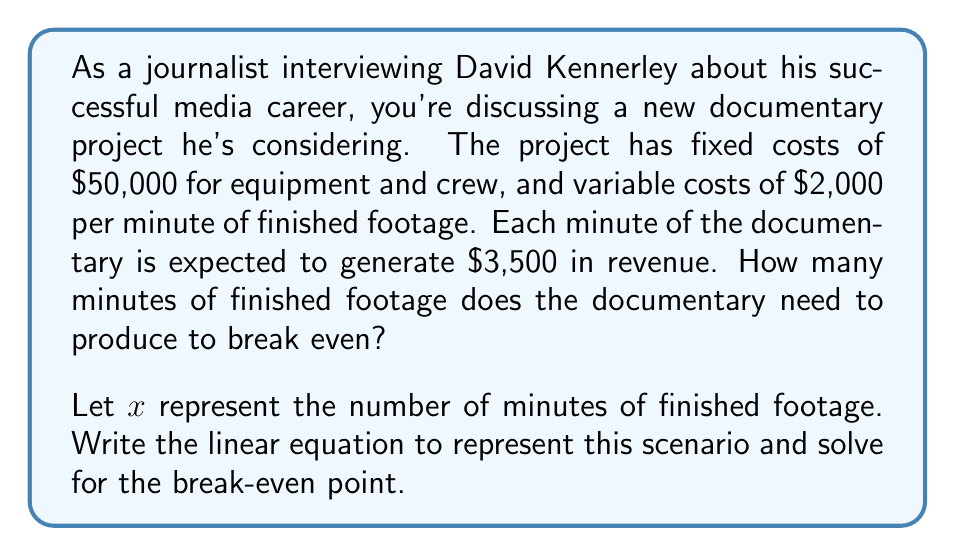What is the answer to this math problem? To solve this problem, we need to set up a linear equation representing the total revenue and total costs, then find the point where they are equal. This is the break-even point.

1. Define the variables:
   $x$ = number of minutes of finished footage
   
2. Write expressions for revenue and costs:
   Revenue: $R(x) = 3500x$
   Total Cost: $TC(x) = 50000 + 2000x$

3. Set up the break-even equation:
   Revenue = Total Cost
   $$3500x = 50000 + 2000x$$

4. Solve for $x$:
   $$3500x - 2000x = 50000$$
   $$1500x = 50000$$
   $$x = \frac{50000}{1500} = 33.33$$

5. Since we can't have a fractional minute, we round up to the nearest whole number.

The break-even point occurs at 34 minutes of finished footage.

To verify:
At 34 minutes:
Revenue = $3500 * 34 = 119000$
Total Cost = $50000 + (2000 * 34) = 118000$

This confirms that 34 minutes is the first point where revenue exceeds costs.
Answer: The documentary needs to produce 34 minutes of finished footage to break even. 